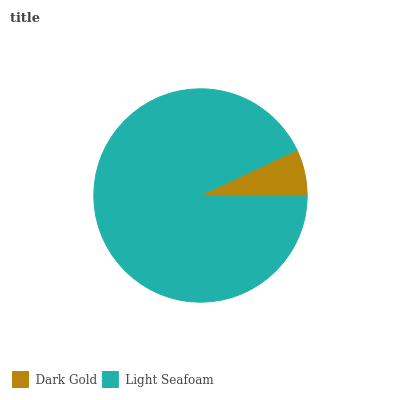Is Dark Gold the minimum?
Answer yes or no. Yes. Is Light Seafoam the maximum?
Answer yes or no. Yes. Is Light Seafoam the minimum?
Answer yes or no. No. Is Light Seafoam greater than Dark Gold?
Answer yes or no. Yes. Is Dark Gold less than Light Seafoam?
Answer yes or no. Yes. Is Dark Gold greater than Light Seafoam?
Answer yes or no. No. Is Light Seafoam less than Dark Gold?
Answer yes or no. No. Is Light Seafoam the high median?
Answer yes or no. Yes. Is Dark Gold the low median?
Answer yes or no. Yes. Is Dark Gold the high median?
Answer yes or no. No. Is Light Seafoam the low median?
Answer yes or no. No. 